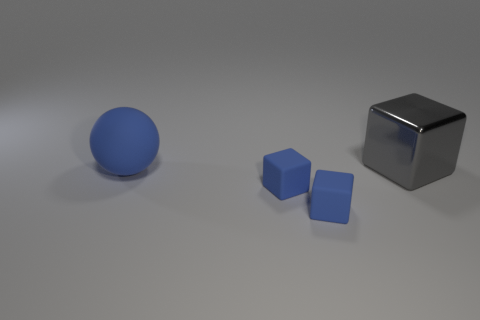Add 3 big things. How many objects exist? 7 Subtract all blocks. How many objects are left? 1 Subtract all large brown cylinders. Subtract all large metallic objects. How many objects are left? 3 Add 2 big objects. How many big objects are left? 4 Add 4 large blue shiny cylinders. How many large blue shiny cylinders exist? 4 Subtract 0 gray cylinders. How many objects are left? 4 